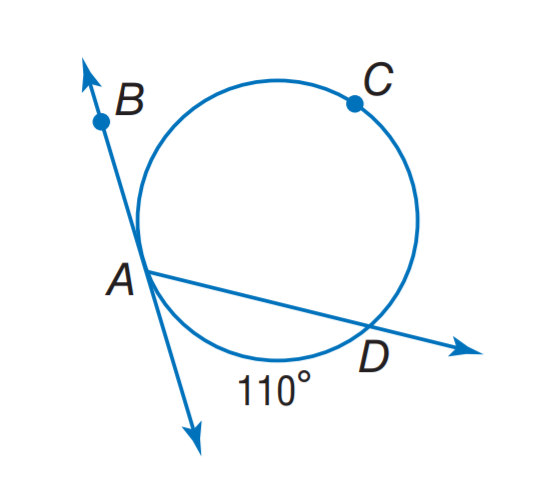Answer the mathemtical geometry problem and directly provide the correct option letter.
Question: Find m \angle D A B.
Choices: A: 55 B: 110 C: 125 D: 135 C 